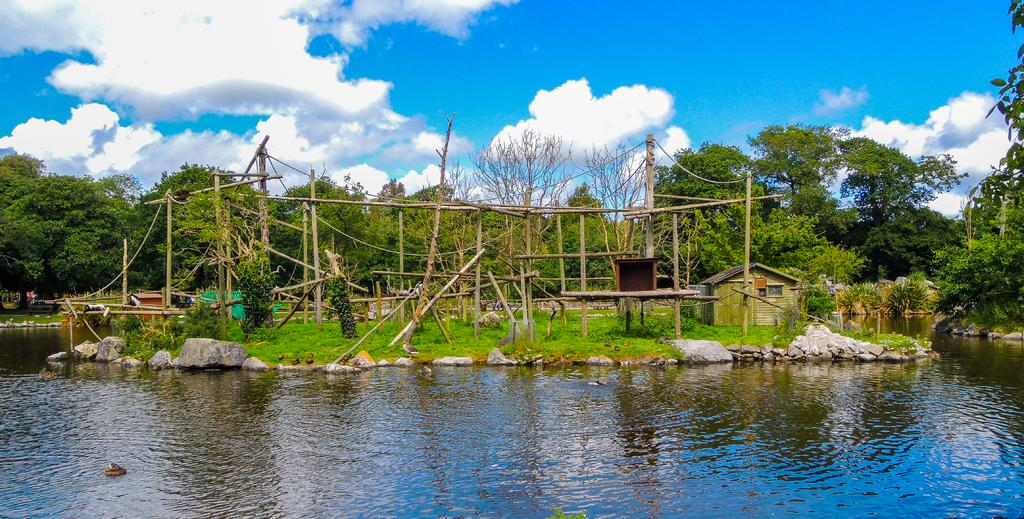What is the primary element visible in the image? There is water in the image. What other natural elements can be seen in the image? There are stones, grass, trees, and plants visible in the image. Are there any man-made structures present in the image? Yes, there is a small hut on the right side of the image. What can be seen in the sky in the image? The sky is visible in the image, and there are clouds present. What type of poles are visible in the image? There are wooden poles in the image. What type of hair can be seen floating in the water in the image? There is no hair visible in the image; it features water, stones, grass, trees, plants, wooden poles, and a small hut. What type of celery is growing near the hut in the image? There is no celery present in the image; it features water, stones, grass, trees, plants, wooden poles, and a small hut. 